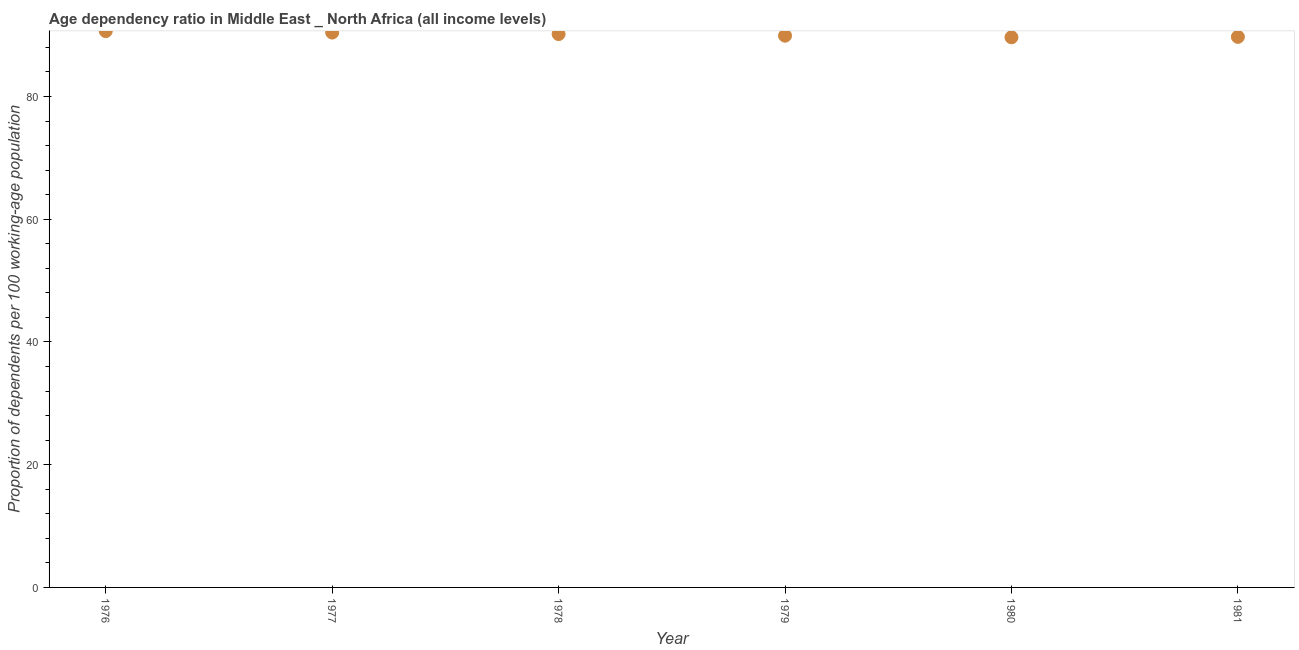What is the age dependency ratio in 1981?
Make the answer very short. 89.72. Across all years, what is the maximum age dependency ratio?
Provide a succinct answer. 90.66. Across all years, what is the minimum age dependency ratio?
Keep it short and to the point. 89.65. In which year was the age dependency ratio maximum?
Offer a very short reply. 1976. What is the sum of the age dependency ratio?
Make the answer very short. 540.54. What is the difference between the age dependency ratio in 1978 and 1979?
Your answer should be compact. 0.26. What is the average age dependency ratio per year?
Provide a short and direct response. 90.09. What is the median age dependency ratio?
Your answer should be very brief. 90.04. What is the ratio of the age dependency ratio in 1976 to that in 1977?
Your answer should be compact. 1. Is the age dependency ratio in 1978 less than that in 1981?
Offer a very short reply. No. Is the difference between the age dependency ratio in 1978 and 1980 greater than the difference between any two years?
Keep it short and to the point. No. What is the difference between the highest and the second highest age dependency ratio?
Offer a terse response. 0.23. What is the difference between the highest and the lowest age dependency ratio?
Your response must be concise. 1. How many dotlines are there?
Give a very brief answer. 1. How many years are there in the graph?
Give a very brief answer. 6. Are the values on the major ticks of Y-axis written in scientific E-notation?
Make the answer very short. No. What is the title of the graph?
Ensure brevity in your answer.  Age dependency ratio in Middle East _ North Africa (all income levels). What is the label or title of the Y-axis?
Offer a terse response. Proportion of dependents per 100 working-age population. What is the Proportion of dependents per 100 working-age population in 1976?
Ensure brevity in your answer.  90.66. What is the Proportion of dependents per 100 working-age population in 1977?
Give a very brief answer. 90.42. What is the Proportion of dependents per 100 working-age population in 1978?
Your answer should be compact. 90.17. What is the Proportion of dependents per 100 working-age population in 1979?
Give a very brief answer. 89.91. What is the Proportion of dependents per 100 working-age population in 1980?
Give a very brief answer. 89.65. What is the Proportion of dependents per 100 working-age population in 1981?
Offer a terse response. 89.72. What is the difference between the Proportion of dependents per 100 working-age population in 1976 and 1977?
Make the answer very short. 0.23. What is the difference between the Proportion of dependents per 100 working-age population in 1976 and 1978?
Offer a terse response. 0.48. What is the difference between the Proportion of dependents per 100 working-age population in 1976 and 1979?
Keep it short and to the point. 0.74. What is the difference between the Proportion of dependents per 100 working-age population in 1976 and 1980?
Give a very brief answer. 1. What is the difference between the Proportion of dependents per 100 working-age population in 1976 and 1981?
Give a very brief answer. 0.93. What is the difference between the Proportion of dependents per 100 working-age population in 1977 and 1978?
Give a very brief answer. 0.25. What is the difference between the Proportion of dependents per 100 working-age population in 1977 and 1979?
Your answer should be compact. 0.51. What is the difference between the Proportion of dependents per 100 working-age population in 1977 and 1980?
Ensure brevity in your answer.  0.77. What is the difference between the Proportion of dependents per 100 working-age population in 1977 and 1981?
Provide a short and direct response. 0.7. What is the difference between the Proportion of dependents per 100 working-age population in 1978 and 1979?
Your answer should be very brief. 0.26. What is the difference between the Proportion of dependents per 100 working-age population in 1978 and 1980?
Your answer should be very brief. 0.52. What is the difference between the Proportion of dependents per 100 working-age population in 1978 and 1981?
Provide a succinct answer. 0.45. What is the difference between the Proportion of dependents per 100 working-age population in 1979 and 1980?
Offer a very short reply. 0.26. What is the difference between the Proportion of dependents per 100 working-age population in 1979 and 1981?
Ensure brevity in your answer.  0.19. What is the difference between the Proportion of dependents per 100 working-age population in 1980 and 1981?
Keep it short and to the point. -0.07. What is the ratio of the Proportion of dependents per 100 working-age population in 1976 to that in 1977?
Your answer should be compact. 1. What is the ratio of the Proportion of dependents per 100 working-age population in 1976 to that in 1978?
Your answer should be very brief. 1. What is the ratio of the Proportion of dependents per 100 working-age population in 1976 to that in 1980?
Give a very brief answer. 1.01. What is the ratio of the Proportion of dependents per 100 working-age population in 1978 to that in 1979?
Offer a terse response. 1. What is the ratio of the Proportion of dependents per 100 working-age population in 1978 to that in 1980?
Offer a terse response. 1.01. What is the ratio of the Proportion of dependents per 100 working-age population in 1978 to that in 1981?
Offer a terse response. 1. What is the ratio of the Proportion of dependents per 100 working-age population in 1979 to that in 1980?
Your response must be concise. 1. What is the ratio of the Proportion of dependents per 100 working-age population in 1980 to that in 1981?
Offer a very short reply. 1. 